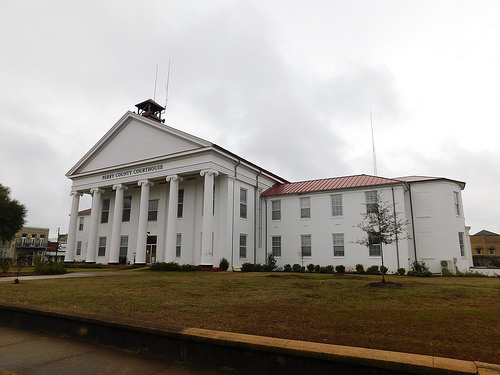<image>
Can you confirm if the building is above the land? No. The building is not positioned above the land. The vertical arrangement shows a different relationship. 